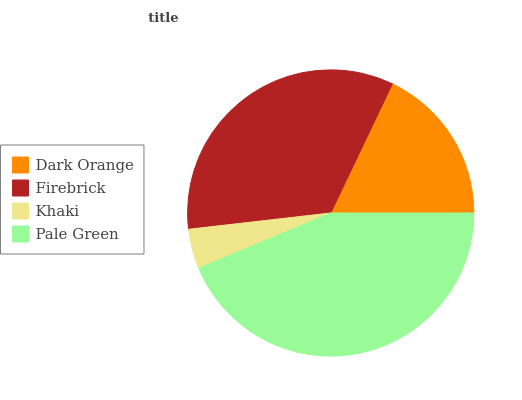Is Khaki the minimum?
Answer yes or no. Yes. Is Pale Green the maximum?
Answer yes or no. Yes. Is Firebrick the minimum?
Answer yes or no. No. Is Firebrick the maximum?
Answer yes or no. No. Is Firebrick greater than Dark Orange?
Answer yes or no. Yes. Is Dark Orange less than Firebrick?
Answer yes or no. Yes. Is Dark Orange greater than Firebrick?
Answer yes or no. No. Is Firebrick less than Dark Orange?
Answer yes or no. No. Is Firebrick the high median?
Answer yes or no. Yes. Is Dark Orange the low median?
Answer yes or no. Yes. Is Khaki the high median?
Answer yes or no. No. Is Firebrick the low median?
Answer yes or no. No. 